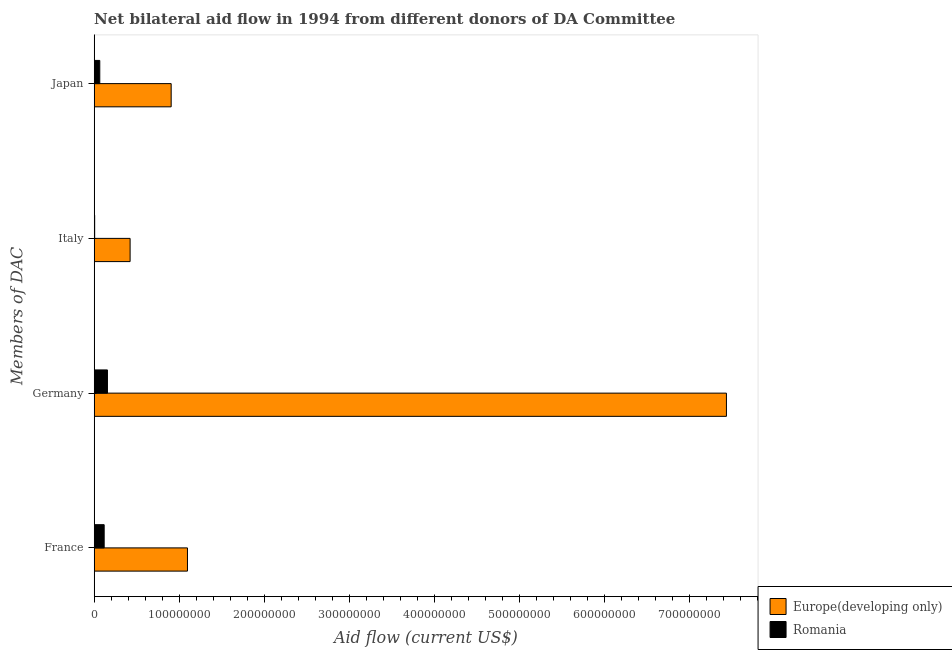How many different coloured bars are there?
Offer a terse response. 2. Are the number of bars per tick equal to the number of legend labels?
Give a very brief answer. Yes. Are the number of bars on each tick of the Y-axis equal?
Your response must be concise. Yes. What is the label of the 2nd group of bars from the top?
Offer a terse response. Italy. What is the amount of aid given by france in Europe(developing only)?
Provide a short and direct response. 1.10e+08. Across all countries, what is the maximum amount of aid given by japan?
Offer a very short reply. 9.05e+07. Across all countries, what is the minimum amount of aid given by japan?
Your answer should be very brief. 6.56e+06. In which country was the amount of aid given by japan maximum?
Offer a terse response. Europe(developing only). In which country was the amount of aid given by italy minimum?
Ensure brevity in your answer.  Romania. What is the total amount of aid given by germany in the graph?
Keep it short and to the point. 7.59e+08. What is the difference between the amount of aid given by france in Europe(developing only) and that in Romania?
Give a very brief answer. 9.79e+07. What is the difference between the amount of aid given by france in Romania and the amount of aid given by japan in Europe(developing only)?
Ensure brevity in your answer.  -7.88e+07. What is the average amount of aid given by italy per country?
Your answer should be compact. 2.14e+07. What is the difference between the amount of aid given by italy and amount of aid given by japan in Europe(developing only)?
Offer a terse response. -4.83e+07. What is the ratio of the amount of aid given by france in Europe(developing only) to that in Romania?
Ensure brevity in your answer.  9.35. Is the amount of aid given by germany in Romania less than that in Europe(developing only)?
Give a very brief answer. Yes. Is the difference between the amount of aid given by italy in Europe(developing only) and Romania greater than the difference between the amount of aid given by france in Europe(developing only) and Romania?
Your response must be concise. No. What is the difference between the highest and the second highest amount of aid given by italy?
Your response must be concise. 4.16e+07. What is the difference between the highest and the lowest amount of aid given by italy?
Give a very brief answer. 4.16e+07. In how many countries, is the amount of aid given by japan greater than the average amount of aid given by japan taken over all countries?
Provide a short and direct response. 1. What does the 1st bar from the top in France represents?
Provide a succinct answer. Romania. What does the 1st bar from the bottom in Japan represents?
Your answer should be compact. Europe(developing only). How many bars are there?
Keep it short and to the point. 8. Are the values on the major ticks of X-axis written in scientific E-notation?
Keep it short and to the point. No. Does the graph contain any zero values?
Provide a succinct answer. No. How many legend labels are there?
Make the answer very short. 2. What is the title of the graph?
Make the answer very short. Net bilateral aid flow in 1994 from different donors of DA Committee. What is the label or title of the Y-axis?
Your response must be concise. Members of DAC. What is the Aid flow (current US$) of Europe(developing only) in France?
Give a very brief answer. 1.10e+08. What is the Aid flow (current US$) in Romania in France?
Offer a very short reply. 1.17e+07. What is the Aid flow (current US$) of Europe(developing only) in Germany?
Offer a very short reply. 7.43e+08. What is the Aid flow (current US$) in Romania in Germany?
Provide a short and direct response. 1.56e+07. What is the Aid flow (current US$) of Europe(developing only) in Italy?
Ensure brevity in your answer.  4.22e+07. What is the Aid flow (current US$) in Romania in Italy?
Ensure brevity in your answer.  5.60e+05. What is the Aid flow (current US$) in Europe(developing only) in Japan?
Provide a short and direct response. 9.05e+07. What is the Aid flow (current US$) in Romania in Japan?
Your answer should be compact. 6.56e+06. Across all Members of DAC, what is the maximum Aid flow (current US$) of Europe(developing only)?
Ensure brevity in your answer.  7.43e+08. Across all Members of DAC, what is the maximum Aid flow (current US$) in Romania?
Give a very brief answer. 1.56e+07. Across all Members of DAC, what is the minimum Aid flow (current US$) of Europe(developing only)?
Your response must be concise. 4.22e+07. Across all Members of DAC, what is the minimum Aid flow (current US$) of Romania?
Ensure brevity in your answer.  5.60e+05. What is the total Aid flow (current US$) of Europe(developing only) in the graph?
Keep it short and to the point. 9.85e+08. What is the total Aid flow (current US$) in Romania in the graph?
Keep it short and to the point. 3.44e+07. What is the difference between the Aid flow (current US$) in Europe(developing only) in France and that in Germany?
Make the answer very short. -6.33e+08. What is the difference between the Aid flow (current US$) in Romania in France and that in Germany?
Provide a short and direct response. -3.86e+06. What is the difference between the Aid flow (current US$) of Europe(developing only) in France and that in Italy?
Ensure brevity in your answer.  6.74e+07. What is the difference between the Aid flow (current US$) in Romania in France and that in Italy?
Keep it short and to the point. 1.12e+07. What is the difference between the Aid flow (current US$) in Europe(developing only) in France and that in Japan?
Your response must be concise. 1.92e+07. What is the difference between the Aid flow (current US$) of Romania in France and that in Japan?
Your answer should be compact. 5.16e+06. What is the difference between the Aid flow (current US$) in Europe(developing only) in Germany and that in Italy?
Ensure brevity in your answer.  7.01e+08. What is the difference between the Aid flow (current US$) in Romania in Germany and that in Italy?
Your answer should be compact. 1.50e+07. What is the difference between the Aid flow (current US$) in Europe(developing only) in Germany and that in Japan?
Make the answer very short. 6.53e+08. What is the difference between the Aid flow (current US$) in Romania in Germany and that in Japan?
Provide a succinct answer. 9.02e+06. What is the difference between the Aid flow (current US$) in Europe(developing only) in Italy and that in Japan?
Provide a short and direct response. -4.83e+07. What is the difference between the Aid flow (current US$) in Romania in Italy and that in Japan?
Ensure brevity in your answer.  -6.00e+06. What is the difference between the Aid flow (current US$) in Europe(developing only) in France and the Aid flow (current US$) in Romania in Germany?
Provide a short and direct response. 9.40e+07. What is the difference between the Aid flow (current US$) of Europe(developing only) in France and the Aid flow (current US$) of Romania in Italy?
Your response must be concise. 1.09e+08. What is the difference between the Aid flow (current US$) in Europe(developing only) in France and the Aid flow (current US$) in Romania in Japan?
Offer a terse response. 1.03e+08. What is the difference between the Aid flow (current US$) in Europe(developing only) in Germany and the Aid flow (current US$) in Romania in Italy?
Keep it short and to the point. 7.43e+08. What is the difference between the Aid flow (current US$) of Europe(developing only) in Germany and the Aid flow (current US$) of Romania in Japan?
Your response must be concise. 7.37e+08. What is the difference between the Aid flow (current US$) of Europe(developing only) in Italy and the Aid flow (current US$) of Romania in Japan?
Make the answer very short. 3.56e+07. What is the average Aid flow (current US$) in Europe(developing only) per Members of DAC?
Provide a succinct answer. 2.46e+08. What is the average Aid flow (current US$) in Romania per Members of DAC?
Make the answer very short. 8.60e+06. What is the difference between the Aid flow (current US$) of Europe(developing only) and Aid flow (current US$) of Romania in France?
Provide a succinct answer. 9.79e+07. What is the difference between the Aid flow (current US$) in Europe(developing only) and Aid flow (current US$) in Romania in Germany?
Provide a short and direct response. 7.28e+08. What is the difference between the Aid flow (current US$) in Europe(developing only) and Aid flow (current US$) in Romania in Italy?
Ensure brevity in your answer.  4.16e+07. What is the difference between the Aid flow (current US$) of Europe(developing only) and Aid flow (current US$) of Romania in Japan?
Your answer should be very brief. 8.39e+07. What is the ratio of the Aid flow (current US$) in Europe(developing only) in France to that in Germany?
Your answer should be compact. 0.15. What is the ratio of the Aid flow (current US$) in Romania in France to that in Germany?
Make the answer very short. 0.75. What is the ratio of the Aid flow (current US$) of Europe(developing only) in France to that in Italy?
Make the answer very short. 2.6. What is the ratio of the Aid flow (current US$) of Romania in France to that in Italy?
Your response must be concise. 20.93. What is the ratio of the Aid flow (current US$) in Europe(developing only) in France to that in Japan?
Your response must be concise. 1.21. What is the ratio of the Aid flow (current US$) in Romania in France to that in Japan?
Ensure brevity in your answer.  1.79. What is the ratio of the Aid flow (current US$) of Europe(developing only) in Germany to that in Italy?
Give a very brief answer. 17.61. What is the ratio of the Aid flow (current US$) of Romania in Germany to that in Italy?
Offer a very short reply. 27.82. What is the ratio of the Aid flow (current US$) of Europe(developing only) in Germany to that in Japan?
Provide a short and direct response. 8.21. What is the ratio of the Aid flow (current US$) in Romania in Germany to that in Japan?
Offer a very short reply. 2.38. What is the ratio of the Aid flow (current US$) of Europe(developing only) in Italy to that in Japan?
Your answer should be compact. 0.47. What is the ratio of the Aid flow (current US$) in Romania in Italy to that in Japan?
Your response must be concise. 0.09. What is the difference between the highest and the second highest Aid flow (current US$) in Europe(developing only)?
Provide a succinct answer. 6.33e+08. What is the difference between the highest and the second highest Aid flow (current US$) in Romania?
Give a very brief answer. 3.86e+06. What is the difference between the highest and the lowest Aid flow (current US$) of Europe(developing only)?
Your answer should be very brief. 7.01e+08. What is the difference between the highest and the lowest Aid flow (current US$) in Romania?
Your answer should be very brief. 1.50e+07. 